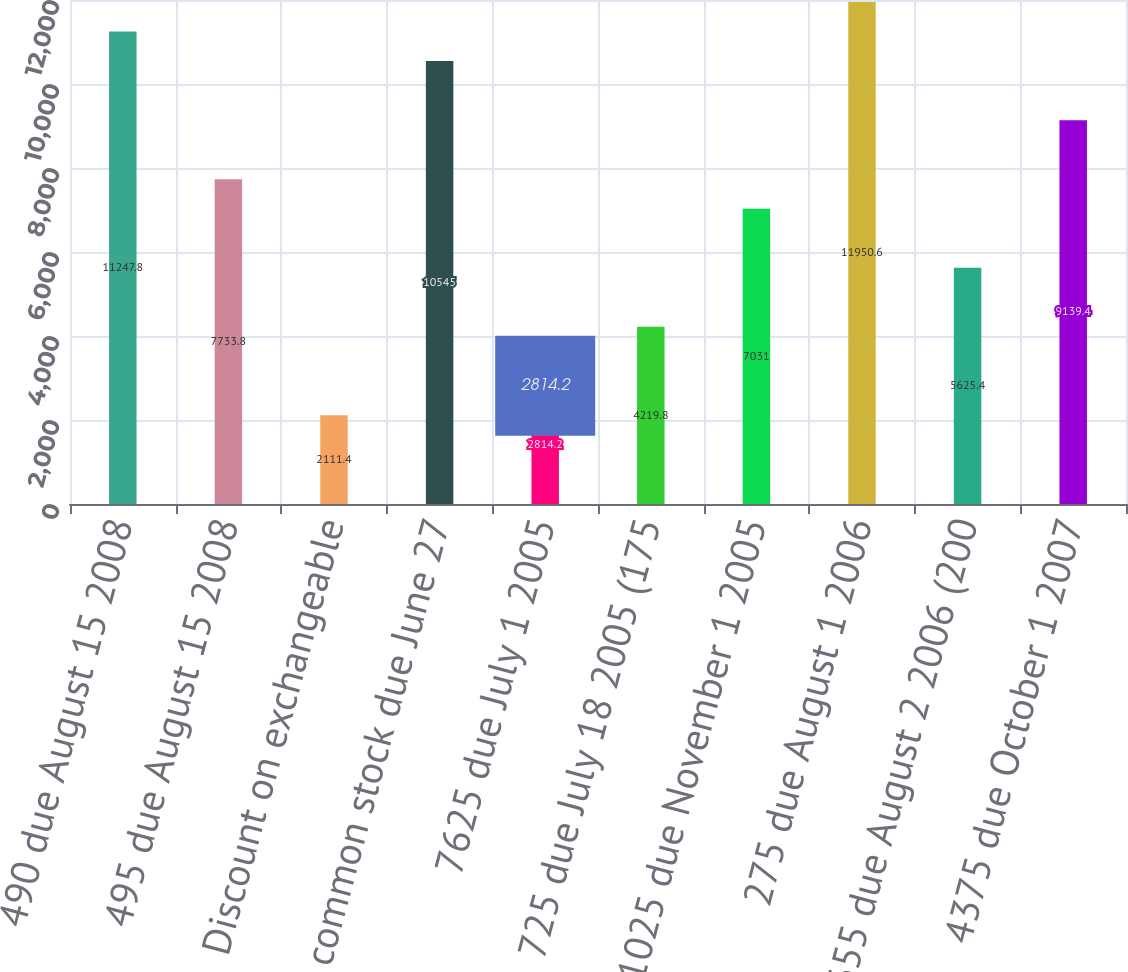Convert chart to OTSL. <chart><loc_0><loc_0><loc_500><loc_500><bar_chart><fcel>490 due August 15 2008<fcel>495 due August 15 2008<fcel>Discount on exchangeable<fcel>Devon common stock due June 27<fcel>7625 due July 1 2005<fcel>725 due July 18 2005 (175<fcel>1025 due November 1 2005<fcel>275 due August 1 2006<fcel>655 due August 2 2006 (200<fcel>4375 due October 1 2007<nl><fcel>11247.8<fcel>7733.8<fcel>2111.4<fcel>10545<fcel>2814.2<fcel>4219.8<fcel>7031<fcel>11950.6<fcel>5625.4<fcel>9139.4<nl></chart> 